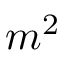<formula> <loc_0><loc_0><loc_500><loc_500>m ^ { 2 }</formula> 